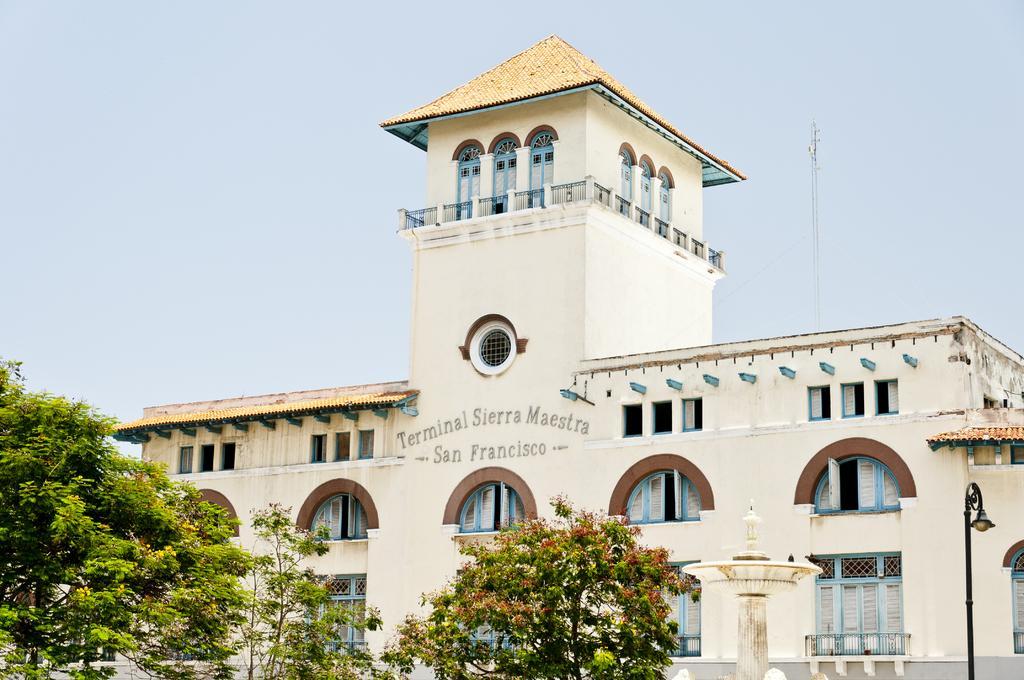How would you summarize this image in a sentence or two? In this image there is the sky towards the top of the image, there is a building, there is text on the building, there are windows, there are trees towards the bottom of the image, there is a pole, there is a streetlight, there is an object behind the building that looks like a tower. 